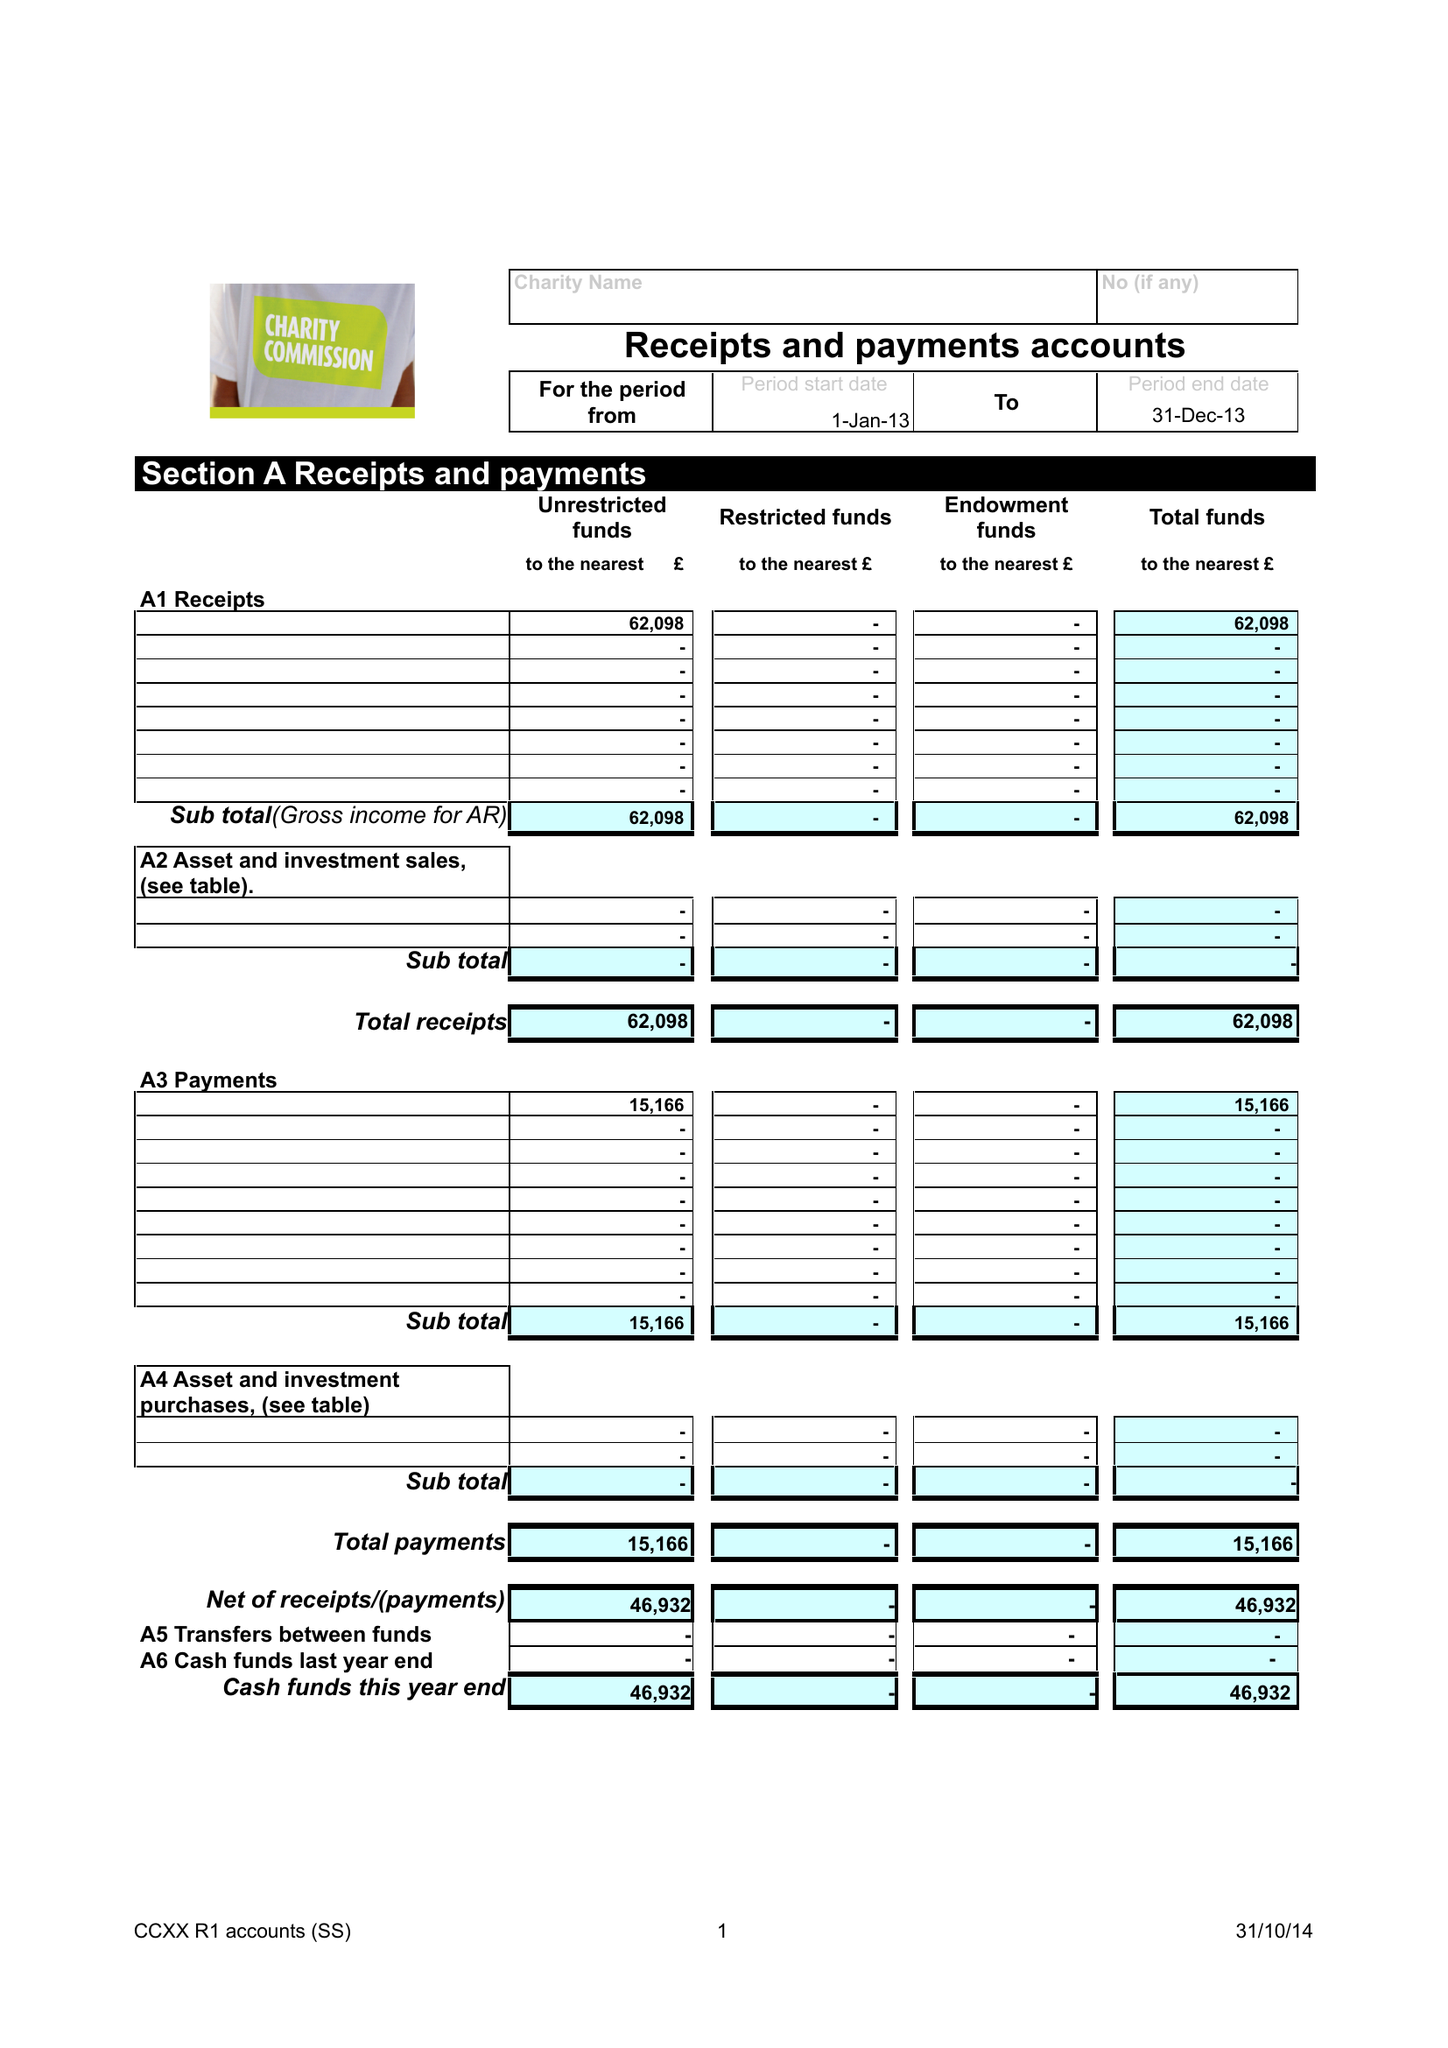What is the value for the income_annually_in_british_pounds?
Answer the question using a single word or phrase. 62098.00 